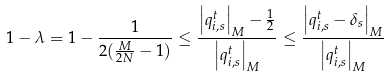<formula> <loc_0><loc_0><loc_500><loc_500>1 - \lambda = 1 - \frac { 1 } { 2 ( \frac { M } { 2 N } - 1 ) } \leq \frac { \left | q _ { i , s } ^ { t } \right | _ { M } - \frac { 1 } { 2 } } { \left | q _ { i , s } ^ { t } \right | _ { M } } \leq \frac { \left | q _ { i , s } ^ { t } - \delta _ { s } \right | _ { M } } { \left | q _ { i , s } ^ { t } \right | _ { M } }</formula> 